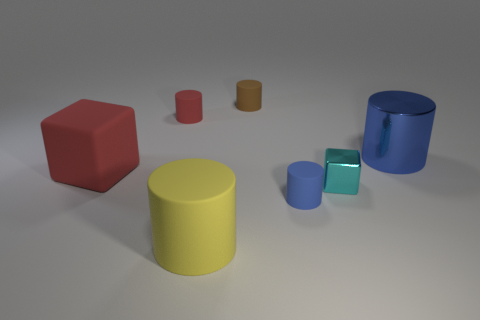Subtract all metallic cylinders. How many cylinders are left? 4 Subtract all red cylinders. How many cylinders are left? 4 Subtract 2 blocks. How many blocks are left? 0 Add 2 large red blocks. How many objects exist? 9 Subtract all cubes. How many objects are left? 5 Add 7 tiny cyan things. How many tiny cyan things exist? 8 Subtract 1 cyan blocks. How many objects are left? 6 Subtract all green cylinders. Subtract all blue spheres. How many cylinders are left? 5 Subtract all cyan balls. How many cyan cubes are left? 1 Subtract all tiny matte objects. Subtract all shiny cylinders. How many objects are left? 3 